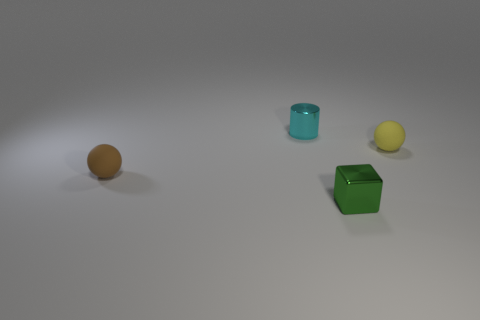How many other objects are the same shape as the yellow rubber object?
Give a very brief answer. 1. What is the shape of the thing that is the same material as the yellow sphere?
Make the answer very short. Sphere. There is a tiny cylinder behind the tiny yellow rubber thing behind the tiny metal thing in front of the shiny cylinder; what is its material?
Provide a short and direct response. Metal. There is a shiny cylinder; does it have the same size as the metal object that is in front of the cyan object?
Keep it short and to the point. Yes. There is another tiny object that is the same shape as the tiny yellow rubber thing; what is its material?
Keep it short and to the point. Rubber. There is a matte ball that is in front of the ball that is to the right of the metal object behind the green metal block; how big is it?
Provide a succinct answer. Small. Is the brown sphere the same size as the cube?
Offer a very short reply. Yes. There is a ball to the left of the rubber sphere that is behind the brown object; what is it made of?
Give a very brief answer. Rubber. There is a small cyan thing that is on the right side of the brown thing; is it the same shape as the matte object that is left of the tiny yellow matte object?
Your answer should be compact. No. Are there the same number of metal cubes behind the shiny cube and small green things?
Give a very brief answer. No. 